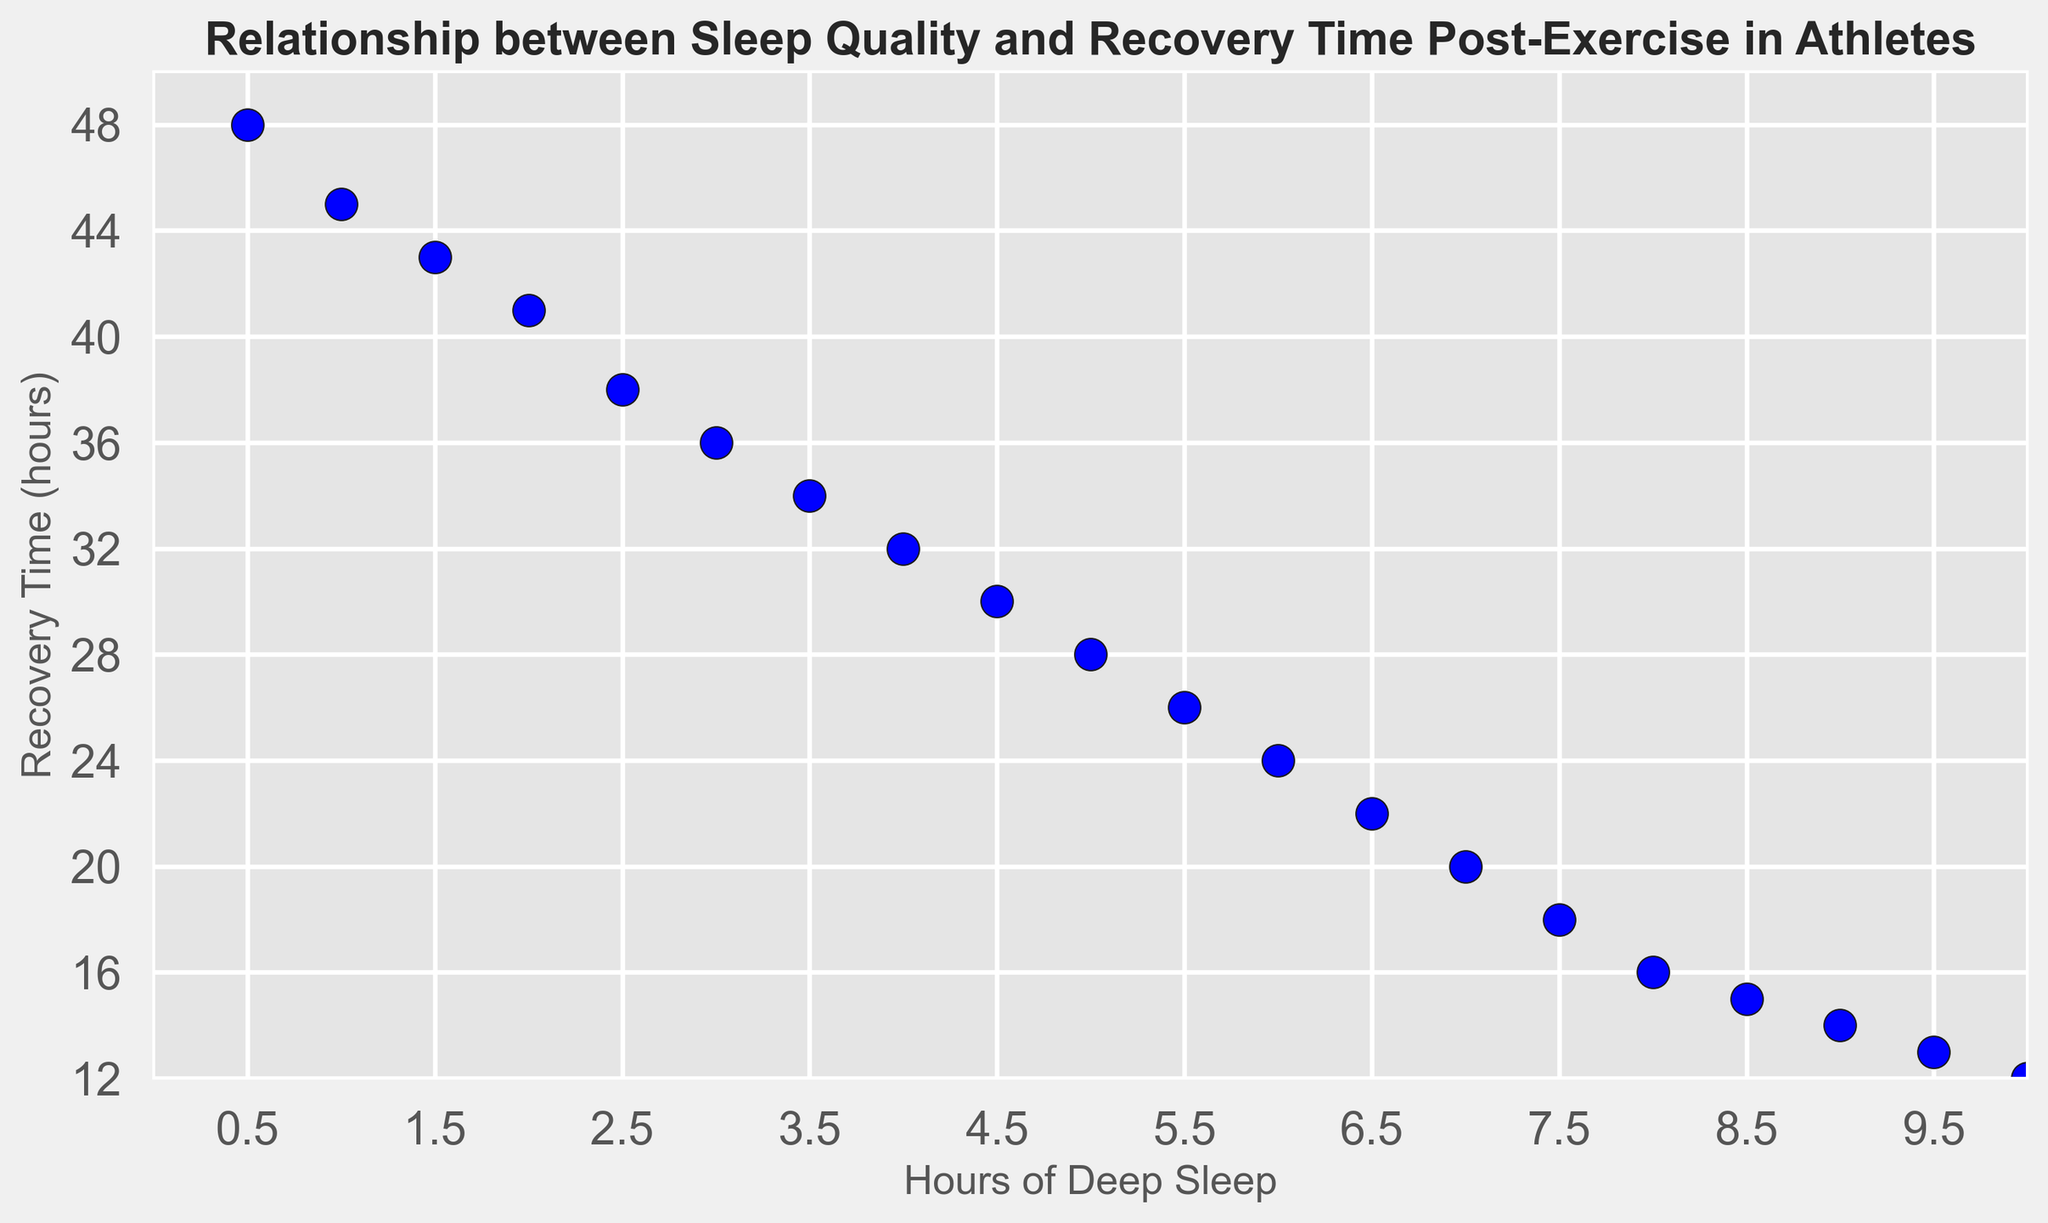What trend do you observe between hours of deep sleep and recovery time post-exercise? Visual observation shows that as the hours of deep sleep increase, the recovery time post-exercise decreases.
Answer: Recovery time decreases with more deep sleep What is the recovery time for athletes who get 5 hours of deep sleep? By locating the data point corresponding to 5 hours of deep sleep on the x-axis and observing its y-coordinate, the recovery time is found to be 28 hours.
Answer: 28 hours At what range of deep sleep hours does recovery time drop to below 20 hours? Looking at the plot, recovery time falls below 20 hours when the hours of deep sleep are greater than or equal to 7 hours.
Answer: ≥ 7 hours How much recovery time is reduced when increasing deep sleep from 2 hours to 6 hours? Recovery time at 2 hours of deep sleep is 41 hours. Recovery time at 6 hours of deep sleep is 24 hours. The reduction is 41 - 24 = 17 hours.
Answer: 17 hours Which data point shows the shortest recovery time, and what are the corresponding hours of deep sleep? The shortest recovery time is represented by the lowest point on the plot, which occurs at 12 hours of recovery time. The corresponding hours of deep sleep are 10 hours.
Answer: 10 hours What is the median recovery time depicted in the figure? The dataset includes 20 data points. Arranged in ascending order, the median is the average of the 10th and 11th values in the list: (28 + 26)/2 = 27 hours.
Answer: 27 hours Are there any athletes with fewer than 2 hours of deep sleep but more than 40 hours of recovery time? The plot shows points for deep sleep hours of 0.5, 1, and 1.5 with recovery times of 48, 45, and 43 hours respectively, all of which are more than 40 hours.
Answer: Yes How is the relationship between sleep quality and recovery time illustrated in terms of the visual appearance of the plot points? Points are scattered in a downward linear trend from left to right, indicating an inverse relationship between sleep quality and recovery time.
Answer: Inverse relationship 